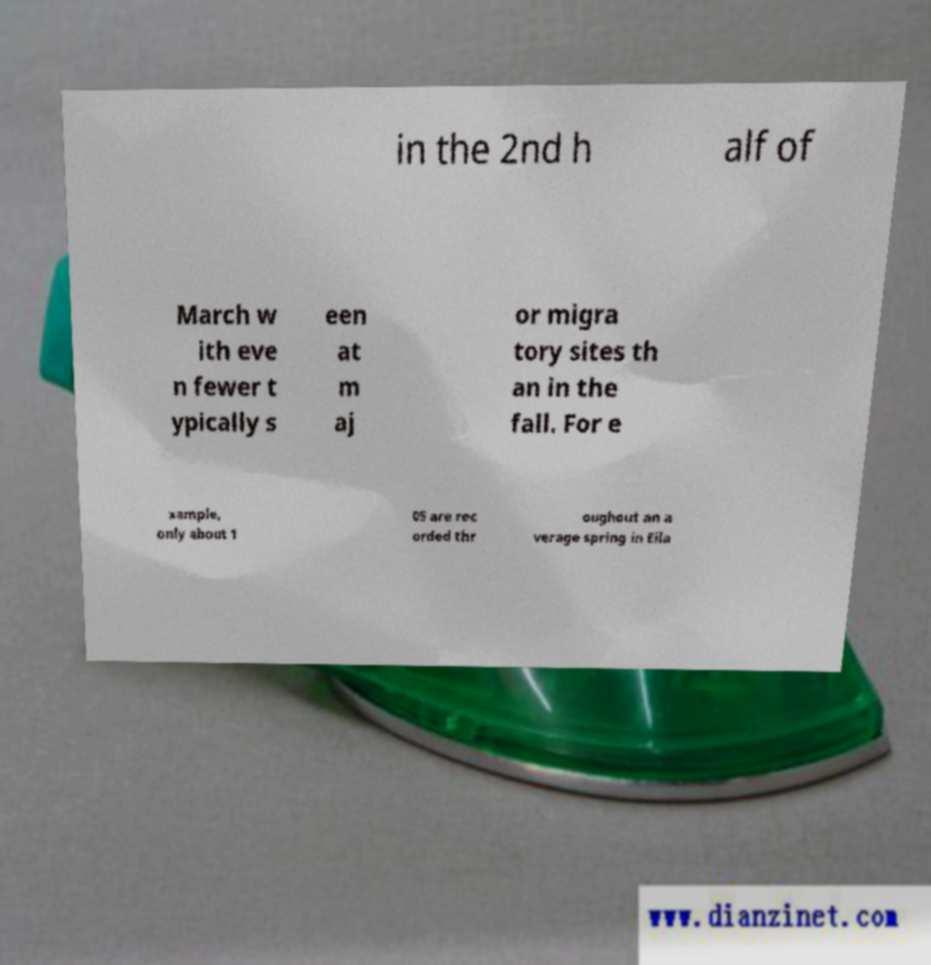What messages or text are displayed in this image? I need them in a readable, typed format. in the 2nd h alf of March w ith eve n fewer t ypically s een at m aj or migra tory sites th an in the fall. For e xample, only about 1 05 are rec orded thr oughout an a verage spring in Eila 